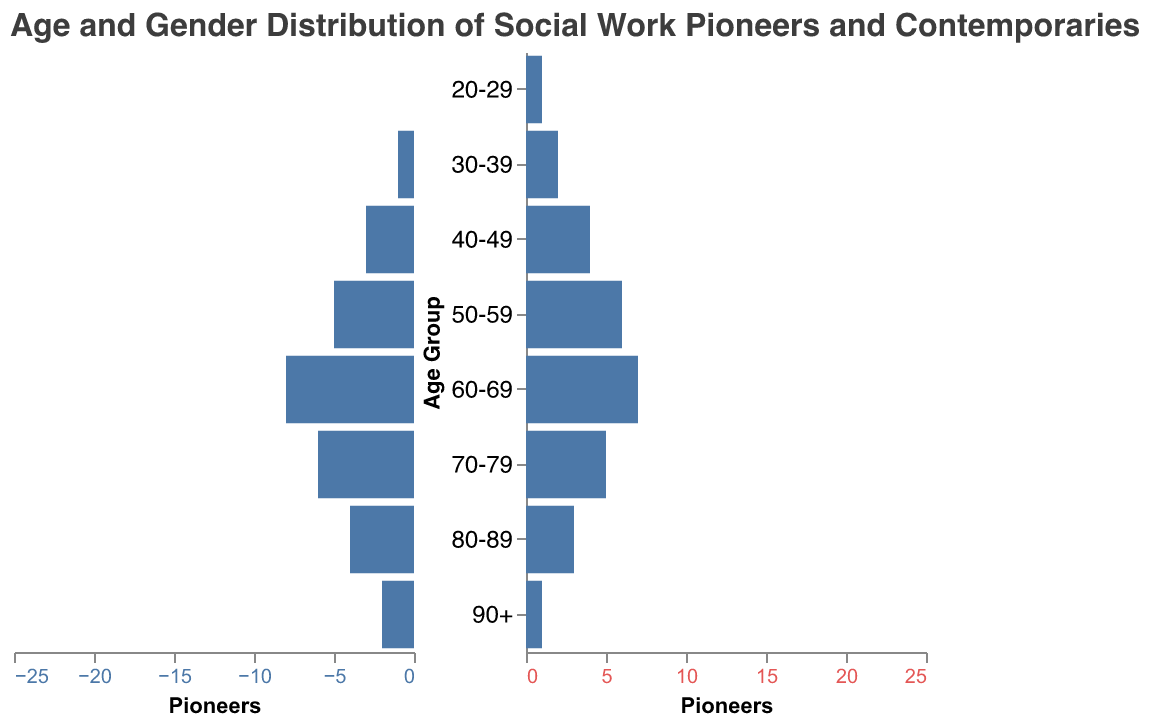What is the title of the chart? The title is displayed at the top of the chart and typically provides a summary of what the chart is about. Here, the title reads "Age and Gender Distribution of Social Work Pioneers and Contemporaries".
Answer: Age and Gender Distribution of Social Work Pioneers and Contemporaries How many male and female pioneers are there in the 50-59 age group? In the population pyramid, the bars for the 50-59 age group show the counts for male and female pioneers separately. According to the chart, there are 5 male pioneers and 6 female pioneers.
Answer: Male: 5, Female: 6 Which age group has the highest number of female contemporaries? The height of the bars on the female contemporary side indicates the count for each age group. The highest bar for female contemporaries is in the 50-59 age group, showing 25 individuals.
Answer: 50-59 Are there more female pioneers or female contemporaries in the 40-49 age group? By comparing the bars for female pioneers and female contemporaries in the 40-49 age group, we see that there are 4 female pioneers and 18 female contemporaries.
Answer: Female contemporaries What is the total number of contemporaries in the 60-69 age group? Add the number of male (18) and female (22) contemporaries in the 60-69 age group: 18 + 22.
Answer: 40 Which age group has no male pioneers? By looking at the bars for male pioneers across different age groups, we see that the 20-29 age group has a count of zero for male pioneers.
Answer: 20-29 How does the number of male pioneers compare to female pioneers in the 70-79 age group? Looking at the bars for male and female pioneers in the 70-79 age group, we see there are 6 male pioneers and 5 female pioneers, indicating there is one more male pioneer than female.
Answer: More male pioneers What is the difference in the number of male pioneers between the 60-69 and 90+ age groups? Subtract the number of male pioneers in the 90+ age group (2) from the 60-69 age group (8): 8 - 2.
Answer: 6 In which age group do we see the smallest difference between male and female contemporaries? Calculate the absolute differences for all age groups: 20-29 (2), 30-39 (4), 40-49 (3), 50-59 (5), 60-69 (4), 70-79 (3), 80-89 (2), 90+ (1). The smallest difference is in the 90+ age group.
Answer: 90+ What percentage of female pioneers are in the 50-59 age group out of the total female pioneers? First, find the total number of female pioneers: 1 + 2 + 4 + 6 + 7 + 5 + 3 + 1 = 29. Then calculate the percentage for the 50-59 age group: (6 / 29) * 100.
Answer: 20.69% 